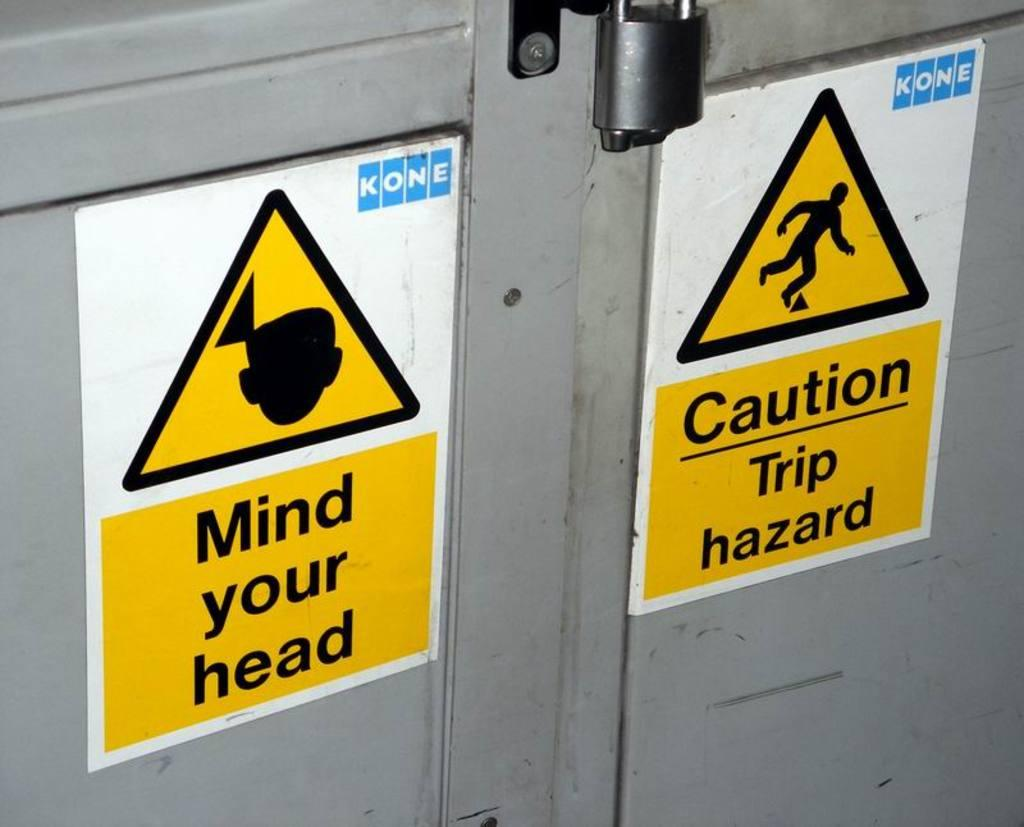<image>
Write a terse but informative summary of the picture. Two warning signs say Mind your head and Trip hazard. 